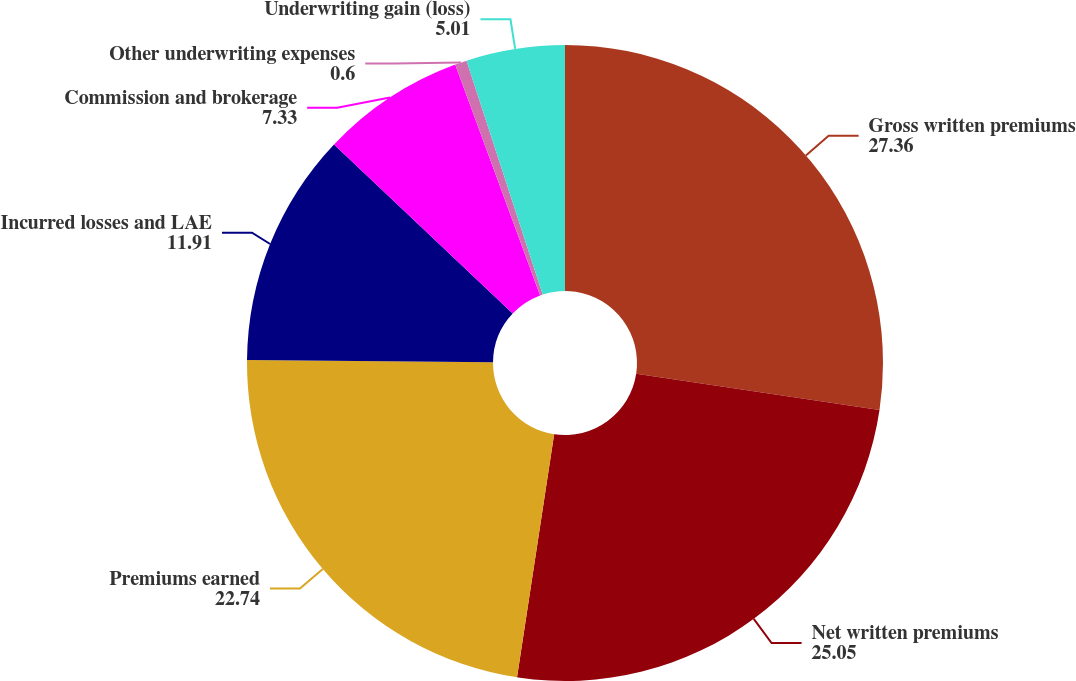<chart> <loc_0><loc_0><loc_500><loc_500><pie_chart><fcel>Gross written premiums<fcel>Net written premiums<fcel>Premiums earned<fcel>Incurred losses and LAE<fcel>Commission and brokerage<fcel>Other underwriting expenses<fcel>Underwriting gain (loss)<nl><fcel>27.36%<fcel>25.05%<fcel>22.74%<fcel>11.91%<fcel>7.33%<fcel>0.6%<fcel>5.01%<nl></chart> 